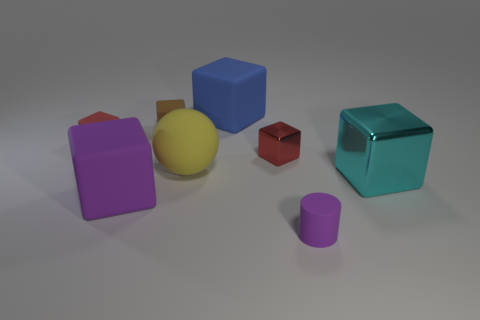Subtract all cyan cylinders. How many red cubes are left? 2 Subtract all large matte blocks. How many blocks are left? 4 Add 2 tiny red blocks. How many objects exist? 10 Subtract all blue cubes. How many cubes are left? 5 Subtract 1 cubes. How many cubes are left? 5 Subtract all brown cubes. Subtract all green cylinders. How many cubes are left? 5 Add 8 tiny brown rubber cubes. How many tiny brown rubber cubes are left? 9 Add 1 matte cylinders. How many matte cylinders exist? 2 Subtract 2 red cubes. How many objects are left? 6 Subtract all cubes. How many objects are left? 2 